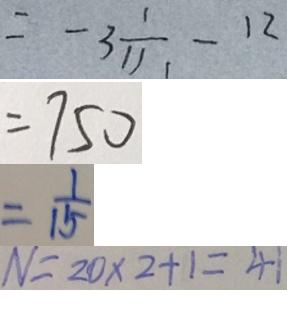<formula> <loc_0><loc_0><loc_500><loc_500>= - 3 \frac { 1 } { 1 1 1 } - 1 2 
 = 7 5 0 
 = \frac { 1 } { 1 5 } 
 N = 2 0 \times 2 + 1 = 4 1</formula> 